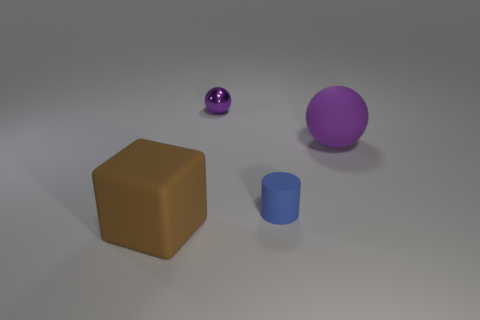How many other small cylinders have the same color as the tiny matte cylinder?
Provide a succinct answer. 0. What number of things are either small blue matte objects or brown shiny things?
Offer a terse response. 1. What is the shape of the purple thing that is the same size as the blue cylinder?
Offer a terse response. Sphere. What number of tiny objects are both behind the large purple sphere and in front of the big purple sphere?
Your response must be concise. 0. There is a tiny thing behind the tiny blue matte object; what is its material?
Offer a very short reply. Metal. There is a blue cylinder that is made of the same material as the large brown cube; what is its size?
Your response must be concise. Small. There is a purple thing that is in front of the tiny metal thing; is its size the same as the matte thing that is in front of the tiny rubber cylinder?
Offer a terse response. Yes. There is a purple ball that is the same size as the blue matte cylinder; what is it made of?
Your answer should be compact. Metal. What is the material of the object that is on the left side of the blue matte cylinder and behind the matte cylinder?
Your answer should be compact. Metal. Is there a small blue matte thing?
Your answer should be very brief. Yes. 